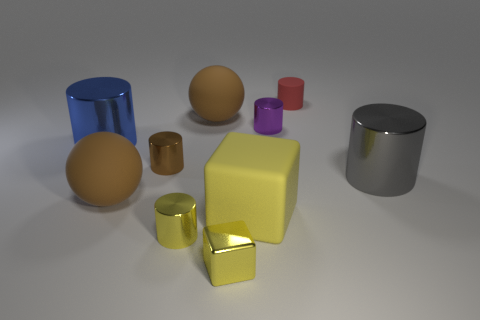How many brown things are small metal cubes or big balls?
Your answer should be compact. 2. Is there anything else that has the same material as the tiny cube?
Keep it short and to the point. Yes. There is a gray object that is the same shape as the large blue metal object; what is it made of?
Your answer should be very brief. Metal. Are there an equal number of purple objects that are behind the purple cylinder and purple shiny cylinders?
Keep it short and to the point. No. There is a metal cylinder that is to the left of the large gray metal cylinder and to the right of the yellow cylinder; what is its size?
Provide a succinct answer. Small. Are there any other things that have the same color as the big block?
Your answer should be very brief. Yes. What size is the matte sphere in front of the big cylinder that is left of the tiny red rubber object?
Keep it short and to the point. Large. What color is the cylinder that is both to the left of the gray metal object and in front of the small brown shiny object?
Provide a succinct answer. Yellow. What number of other things are there of the same size as the red thing?
Offer a very short reply. 4. There is a blue shiny cylinder; is it the same size as the metal cylinder behind the blue thing?
Make the answer very short. No. 